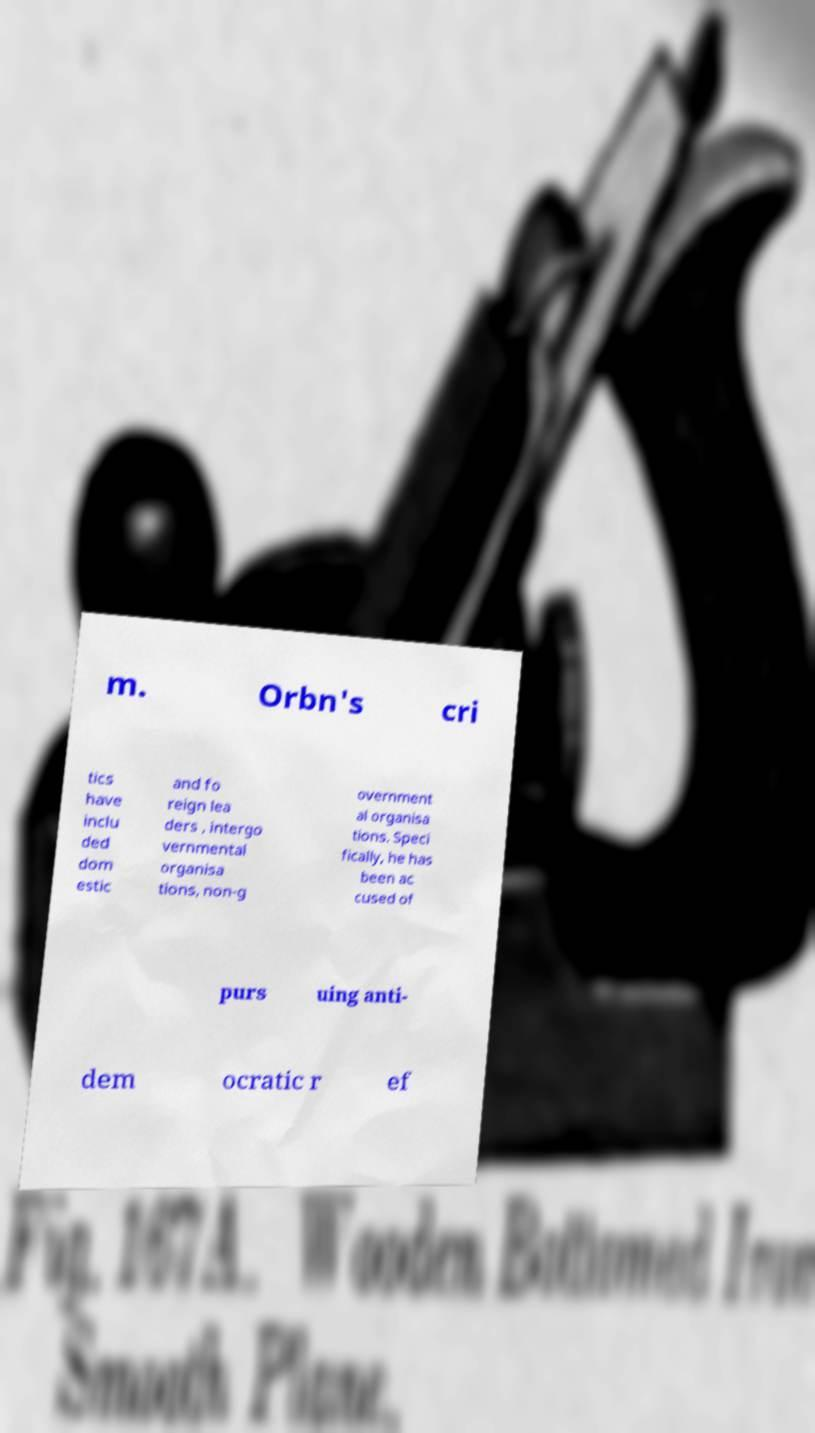For documentation purposes, I need the text within this image transcribed. Could you provide that? m. Orbn's cri tics have inclu ded dom estic and fo reign lea ders , intergo vernmental organisa tions, non-g overnment al organisa tions. Speci fically, he has been ac cused of purs uing anti- dem ocratic r ef 